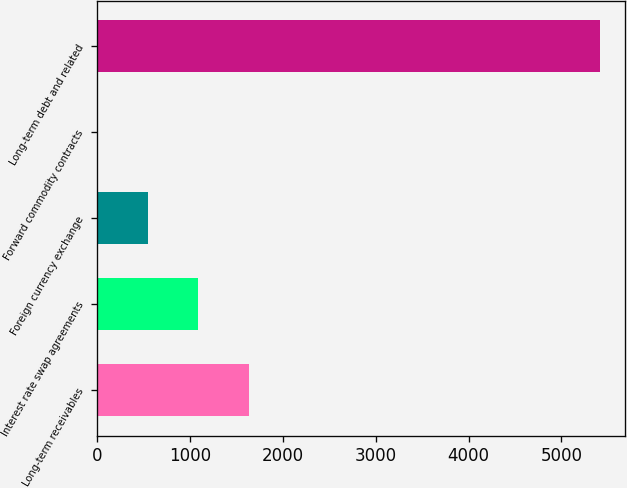Convert chart to OTSL. <chart><loc_0><loc_0><loc_500><loc_500><bar_chart><fcel>Long-term receivables<fcel>Interest rate swap agreements<fcel>Foreign currency exchange<fcel>Forward commodity contracts<fcel>Long-term debt and related<nl><fcel>1630.3<fcel>1090.2<fcel>550.1<fcel>10<fcel>5411<nl></chart> 